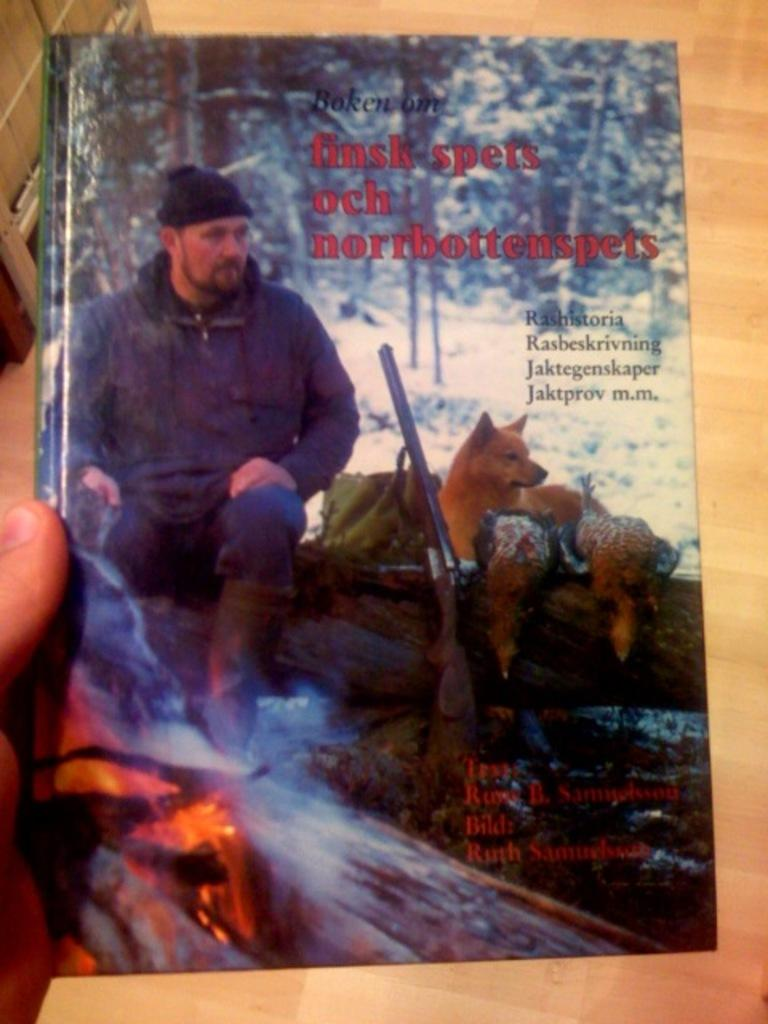What is the human hand holding in the image? The human hand is holding a book in the image. What can be seen on the cover page of the book? The cover page of the book has a person, animals, trees, and a gun on it. What is the color of the floor in the image? The floor in the image is brown colored. Is the person wearing a sweater while running in the image? There is no person wearing a sweater and running in the image. The image only shows a human hand holding a book. 